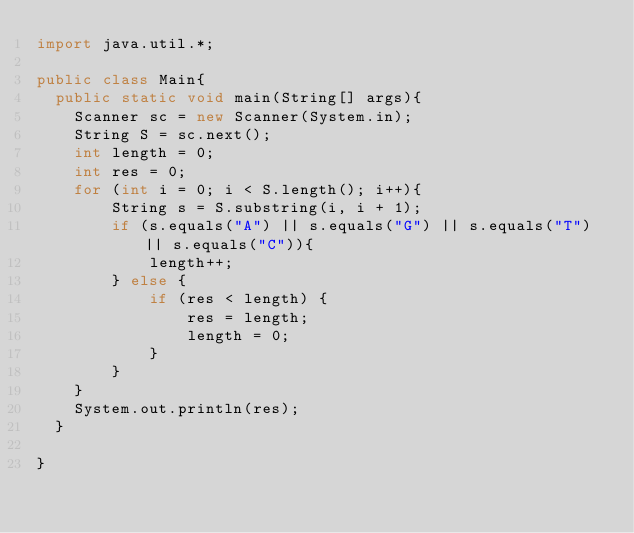<code> <loc_0><loc_0><loc_500><loc_500><_Java_>import java.util.*;
 
public class Main{
  public static void main(String[] args){
    Scanner sc = new Scanner(System.in);
    String S = sc.next();
    int length = 0;
    int res = 0;
    for (int i = 0; i < S.length(); i++){
        String s = S.substring(i, i + 1);
        if (s.equals("A") || s.equals("G") || s.equals("T") || s.equals("C")){
            length++;
        } else {
            if (res < length) {
                res = length;
                length = 0;
            }
        }
    }
    System.out.println(res);
  }
  
}
</code> 